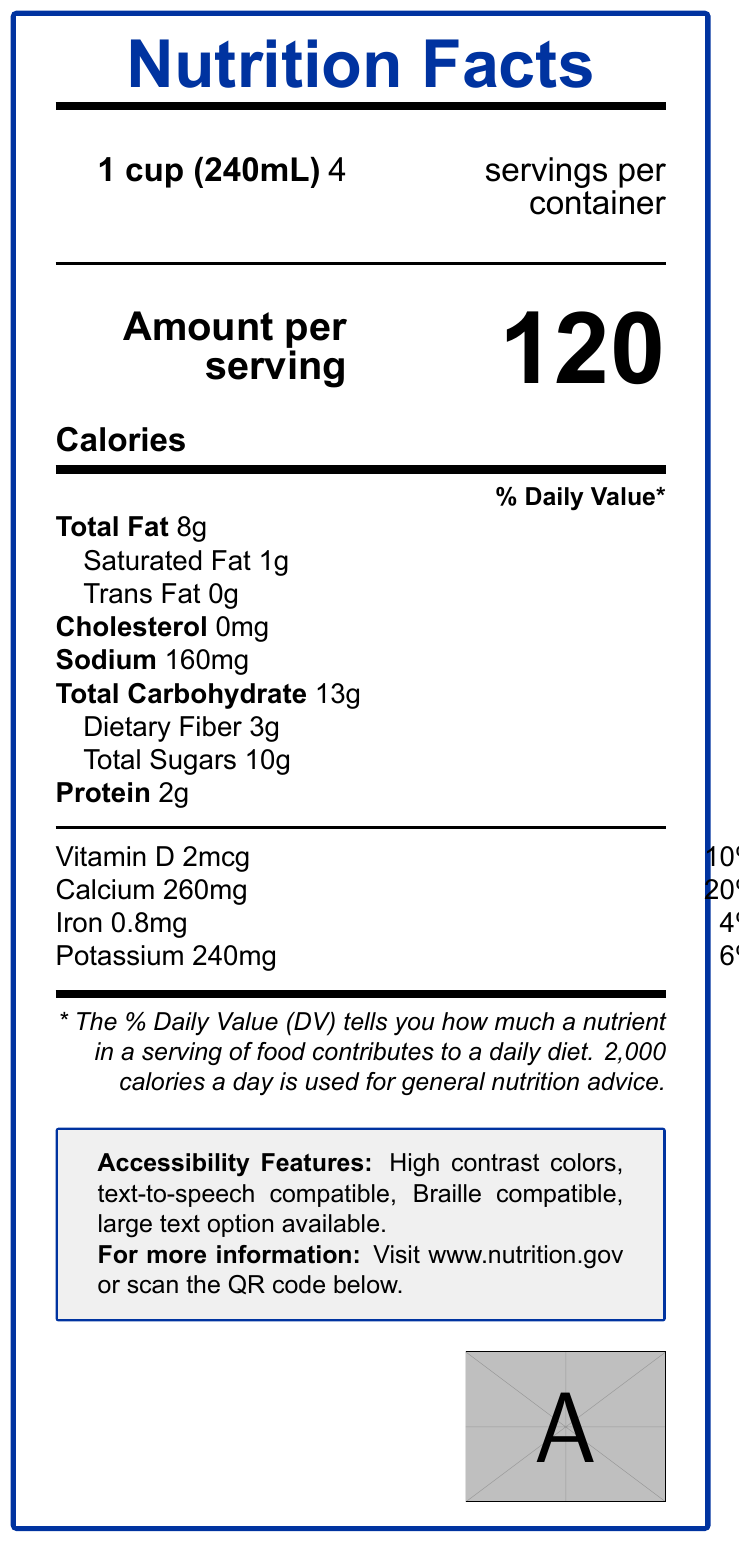What is the serving size for this product? The serving size is prominently displayed at the top left of the label in bold font.
Answer: 1 cup (240mL) How many servings per container are there? The number of servings per container is shown next to the serving size at the top right of the label.
Answer: 4 How many calories are in one serving? The number of calories per serving is displayed in large font in the middle section of the label.
Answer: 120 What is the total fat content per serving? The total fat content is listed in the nutrient information section, under "Total Fat".
Answer: 8g What is the percentage of the daily value for sodium? The daily value percentage for sodium is shown in the nutrient information section next to the sodium content.
Answer: 7% What are the accessibility features included on the label? The accessibility features are listed in the text box at the bottom of the label.
Answer: High contrast colors, text-to-speech compatible, Braille compatible, large text option available Which of the following is NOT listed as a nutrient on the label? A. Cholesterol B. Fiber C. Vitamin C D. Protein Vitamin C is not listed among the nutrients on the label, while cholesterol, fiber, and protein are included.
Answer: C. Vitamin C How much dietary fiber is in one serving? A. 1g B. 3g C. 5g D. 7g The dietary fiber content is listed as 3g in the nutrient information section, with 11% of the daily value.
Answer: B. 3g Does this label include any information about vitamins and minerals? The label includes information about Vitamin D, Calcium, Iron, and Potassium in the bottom nutrient section.
Answer: Yes Summarize the main purpose of this document. The document primarily provides a user-friendly presentation of nutritional information, with special features to aid those with visual impairments and the elderly.
Answer: This document is a Nutrition Facts label designed to be accessible and easy to read for senior citizens and visually impaired individuals. It includes detailed nutritional information, accessibility features, and compliance with government regulations. When was the government regulation last updated? The exact date when the government regulation was last updated is not included in the visual information provided in the document.
Answer: Cannot be determined 